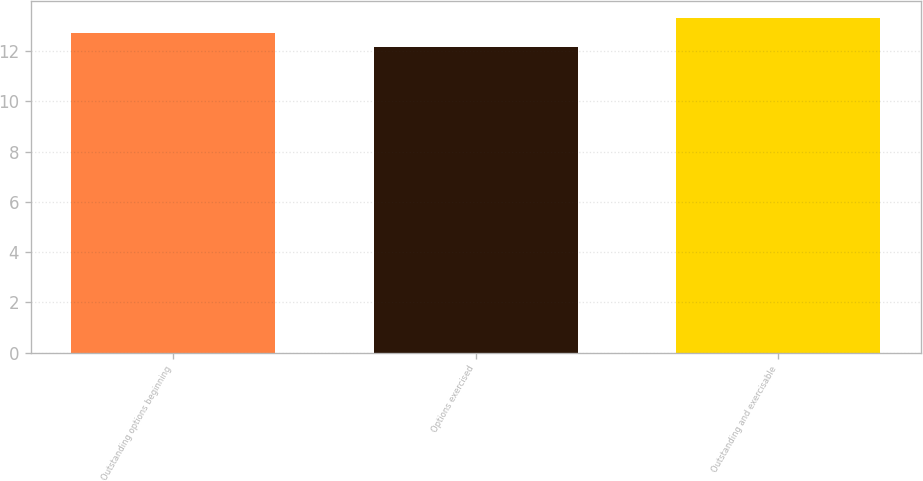<chart> <loc_0><loc_0><loc_500><loc_500><bar_chart><fcel>Outstanding options beginning<fcel>Options exercised<fcel>Outstanding and exercisable<nl><fcel>12.71<fcel>12.15<fcel>13.33<nl></chart> 